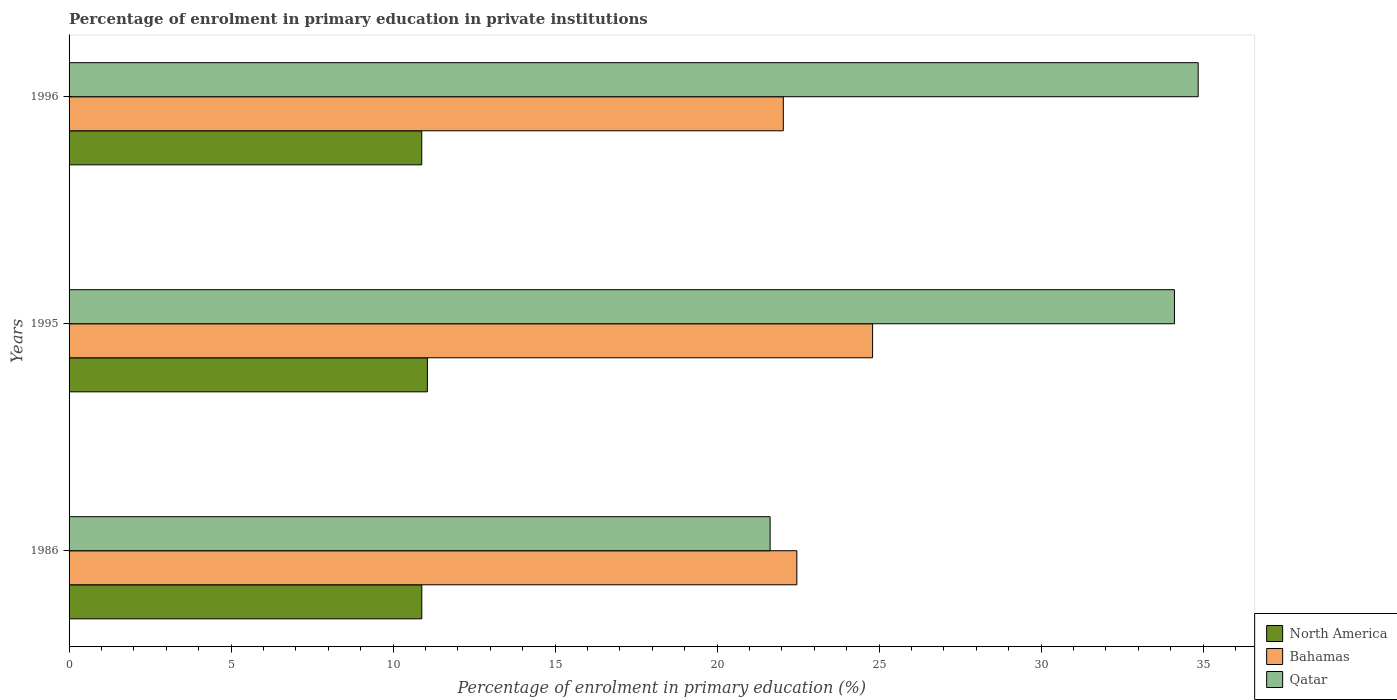How many different coloured bars are there?
Offer a terse response. 3. Are the number of bars per tick equal to the number of legend labels?
Your answer should be compact. Yes. How many bars are there on the 2nd tick from the top?
Keep it short and to the point. 3. How many bars are there on the 1st tick from the bottom?
Provide a succinct answer. 3. In how many cases, is the number of bars for a given year not equal to the number of legend labels?
Provide a short and direct response. 0. What is the percentage of enrolment in primary education in Bahamas in 1995?
Your answer should be compact. 24.8. Across all years, what is the maximum percentage of enrolment in primary education in Qatar?
Your answer should be very brief. 34.85. Across all years, what is the minimum percentage of enrolment in primary education in Qatar?
Keep it short and to the point. 21.64. In which year was the percentage of enrolment in primary education in Bahamas minimum?
Your response must be concise. 1996. What is the total percentage of enrolment in primary education in Bahamas in the graph?
Offer a very short reply. 69.3. What is the difference between the percentage of enrolment in primary education in Qatar in 1986 and that in 1996?
Make the answer very short. -13.21. What is the difference between the percentage of enrolment in primary education in Bahamas in 1995 and the percentage of enrolment in primary education in Qatar in 1986?
Keep it short and to the point. 3.16. What is the average percentage of enrolment in primary education in North America per year?
Provide a succinct answer. 10.94. In the year 1996, what is the difference between the percentage of enrolment in primary education in Qatar and percentage of enrolment in primary education in Bahamas?
Provide a succinct answer. 12.8. What is the ratio of the percentage of enrolment in primary education in North America in 1986 to that in 1996?
Your response must be concise. 1. Is the difference between the percentage of enrolment in primary education in Qatar in 1986 and 1996 greater than the difference between the percentage of enrolment in primary education in Bahamas in 1986 and 1996?
Give a very brief answer. No. What is the difference between the highest and the second highest percentage of enrolment in primary education in North America?
Ensure brevity in your answer.  0.17. What is the difference between the highest and the lowest percentage of enrolment in primary education in Bahamas?
Your response must be concise. 2.76. In how many years, is the percentage of enrolment in primary education in North America greater than the average percentage of enrolment in primary education in North America taken over all years?
Provide a succinct answer. 1. Is the sum of the percentage of enrolment in primary education in Qatar in 1995 and 1996 greater than the maximum percentage of enrolment in primary education in North America across all years?
Keep it short and to the point. Yes. What does the 1st bar from the top in 1995 represents?
Your response must be concise. Qatar. What does the 2nd bar from the bottom in 1986 represents?
Provide a short and direct response. Bahamas. How many bars are there?
Make the answer very short. 9. Are all the bars in the graph horizontal?
Make the answer very short. Yes. Does the graph contain any zero values?
Offer a terse response. No. Does the graph contain grids?
Keep it short and to the point. No. Where does the legend appear in the graph?
Ensure brevity in your answer.  Bottom right. How many legend labels are there?
Give a very brief answer. 3. What is the title of the graph?
Your answer should be compact. Percentage of enrolment in primary education in private institutions. Does "Malaysia" appear as one of the legend labels in the graph?
Make the answer very short. No. What is the label or title of the X-axis?
Your answer should be compact. Percentage of enrolment in primary education (%). What is the Percentage of enrolment in primary education (%) in North America in 1986?
Offer a terse response. 10.89. What is the Percentage of enrolment in primary education (%) in Bahamas in 1986?
Offer a terse response. 22.46. What is the Percentage of enrolment in primary education (%) of Qatar in 1986?
Offer a terse response. 21.64. What is the Percentage of enrolment in primary education (%) in North America in 1995?
Offer a terse response. 11.06. What is the Percentage of enrolment in primary education (%) in Bahamas in 1995?
Your answer should be compact. 24.8. What is the Percentage of enrolment in primary education (%) in Qatar in 1995?
Offer a very short reply. 34.11. What is the Percentage of enrolment in primary education (%) in North America in 1996?
Offer a terse response. 10.88. What is the Percentage of enrolment in primary education (%) of Bahamas in 1996?
Your answer should be very brief. 22.04. What is the Percentage of enrolment in primary education (%) of Qatar in 1996?
Keep it short and to the point. 34.85. Across all years, what is the maximum Percentage of enrolment in primary education (%) in North America?
Provide a short and direct response. 11.06. Across all years, what is the maximum Percentage of enrolment in primary education (%) in Bahamas?
Your response must be concise. 24.8. Across all years, what is the maximum Percentage of enrolment in primary education (%) of Qatar?
Ensure brevity in your answer.  34.85. Across all years, what is the minimum Percentage of enrolment in primary education (%) of North America?
Your response must be concise. 10.88. Across all years, what is the minimum Percentage of enrolment in primary education (%) of Bahamas?
Your answer should be very brief. 22.04. Across all years, what is the minimum Percentage of enrolment in primary education (%) of Qatar?
Your answer should be compact. 21.64. What is the total Percentage of enrolment in primary education (%) of North America in the graph?
Provide a short and direct response. 32.83. What is the total Percentage of enrolment in primary education (%) in Bahamas in the graph?
Give a very brief answer. 69.3. What is the total Percentage of enrolment in primary education (%) in Qatar in the graph?
Your response must be concise. 90.6. What is the difference between the Percentage of enrolment in primary education (%) of North America in 1986 and that in 1995?
Make the answer very short. -0.17. What is the difference between the Percentage of enrolment in primary education (%) of Bahamas in 1986 and that in 1995?
Provide a succinct answer. -2.34. What is the difference between the Percentage of enrolment in primary education (%) of Qatar in 1986 and that in 1995?
Make the answer very short. -12.48. What is the difference between the Percentage of enrolment in primary education (%) of North America in 1986 and that in 1996?
Your response must be concise. 0. What is the difference between the Percentage of enrolment in primary education (%) of Bahamas in 1986 and that in 1996?
Keep it short and to the point. 0.42. What is the difference between the Percentage of enrolment in primary education (%) of Qatar in 1986 and that in 1996?
Offer a very short reply. -13.21. What is the difference between the Percentage of enrolment in primary education (%) in North America in 1995 and that in 1996?
Provide a short and direct response. 0.17. What is the difference between the Percentage of enrolment in primary education (%) of Bahamas in 1995 and that in 1996?
Offer a terse response. 2.76. What is the difference between the Percentage of enrolment in primary education (%) in Qatar in 1995 and that in 1996?
Ensure brevity in your answer.  -0.73. What is the difference between the Percentage of enrolment in primary education (%) of North America in 1986 and the Percentage of enrolment in primary education (%) of Bahamas in 1995?
Make the answer very short. -13.91. What is the difference between the Percentage of enrolment in primary education (%) in North America in 1986 and the Percentage of enrolment in primary education (%) in Qatar in 1995?
Offer a very short reply. -23.23. What is the difference between the Percentage of enrolment in primary education (%) of Bahamas in 1986 and the Percentage of enrolment in primary education (%) of Qatar in 1995?
Offer a terse response. -11.65. What is the difference between the Percentage of enrolment in primary education (%) in North America in 1986 and the Percentage of enrolment in primary education (%) in Bahamas in 1996?
Provide a succinct answer. -11.16. What is the difference between the Percentage of enrolment in primary education (%) in North America in 1986 and the Percentage of enrolment in primary education (%) in Qatar in 1996?
Your answer should be very brief. -23.96. What is the difference between the Percentage of enrolment in primary education (%) in Bahamas in 1986 and the Percentage of enrolment in primary education (%) in Qatar in 1996?
Make the answer very short. -12.39. What is the difference between the Percentage of enrolment in primary education (%) of North America in 1995 and the Percentage of enrolment in primary education (%) of Bahamas in 1996?
Your answer should be compact. -10.99. What is the difference between the Percentage of enrolment in primary education (%) of North America in 1995 and the Percentage of enrolment in primary education (%) of Qatar in 1996?
Ensure brevity in your answer.  -23.79. What is the difference between the Percentage of enrolment in primary education (%) in Bahamas in 1995 and the Percentage of enrolment in primary education (%) in Qatar in 1996?
Make the answer very short. -10.05. What is the average Percentage of enrolment in primary education (%) of North America per year?
Provide a short and direct response. 10.94. What is the average Percentage of enrolment in primary education (%) in Bahamas per year?
Provide a succinct answer. 23.1. What is the average Percentage of enrolment in primary education (%) of Qatar per year?
Provide a short and direct response. 30.2. In the year 1986, what is the difference between the Percentage of enrolment in primary education (%) in North America and Percentage of enrolment in primary education (%) in Bahamas?
Offer a terse response. -11.57. In the year 1986, what is the difference between the Percentage of enrolment in primary education (%) in North America and Percentage of enrolment in primary education (%) in Qatar?
Provide a succinct answer. -10.75. In the year 1986, what is the difference between the Percentage of enrolment in primary education (%) in Bahamas and Percentage of enrolment in primary education (%) in Qatar?
Your answer should be compact. 0.82. In the year 1995, what is the difference between the Percentage of enrolment in primary education (%) of North America and Percentage of enrolment in primary education (%) of Bahamas?
Your response must be concise. -13.74. In the year 1995, what is the difference between the Percentage of enrolment in primary education (%) in North America and Percentage of enrolment in primary education (%) in Qatar?
Make the answer very short. -23.06. In the year 1995, what is the difference between the Percentage of enrolment in primary education (%) of Bahamas and Percentage of enrolment in primary education (%) of Qatar?
Provide a succinct answer. -9.32. In the year 1996, what is the difference between the Percentage of enrolment in primary education (%) in North America and Percentage of enrolment in primary education (%) in Bahamas?
Your response must be concise. -11.16. In the year 1996, what is the difference between the Percentage of enrolment in primary education (%) in North America and Percentage of enrolment in primary education (%) in Qatar?
Your answer should be very brief. -23.96. In the year 1996, what is the difference between the Percentage of enrolment in primary education (%) in Bahamas and Percentage of enrolment in primary education (%) in Qatar?
Provide a succinct answer. -12.8. What is the ratio of the Percentage of enrolment in primary education (%) in North America in 1986 to that in 1995?
Provide a succinct answer. 0.98. What is the ratio of the Percentage of enrolment in primary education (%) of Bahamas in 1986 to that in 1995?
Make the answer very short. 0.91. What is the ratio of the Percentage of enrolment in primary education (%) of Qatar in 1986 to that in 1995?
Give a very brief answer. 0.63. What is the ratio of the Percentage of enrolment in primary education (%) in Qatar in 1986 to that in 1996?
Provide a succinct answer. 0.62. What is the ratio of the Percentage of enrolment in primary education (%) of North America in 1995 to that in 1996?
Your answer should be compact. 1.02. What is the ratio of the Percentage of enrolment in primary education (%) in Bahamas in 1995 to that in 1996?
Provide a short and direct response. 1.12. What is the ratio of the Percentage of enrolment in primary education (%) of Qatar in 1995 to that in 1996?
Keep it short and to the point. 0.98. What is the difference between the highest and the second highest Percentage of enrolment in primary education (%) of North America?
Ensure brevity in your answer.  0.17. What is the difference between the highest and the second highest Percentage of enrolment in primary education (%) in Bahamas?
Make the answer very short. 2.34. What is the difference between the highest and the second highest Percentage of enrolment in primary education (%) of Qatar?
Provide a succinct answer. 0.73. What is the difference between the highest and the lowest Percentage of enrolment in primary education (%) in North America?
Ensure brevity in your answer.  0.17. What is the difference between the highest and the lowest Percentage of enrolment in primary education (%) in Bahamas?
Ensure brevity in your answer.  2.76. What is the difference between the highest and the lowest Percentage of enrolment in primary education (%) in Qatar?
Provide a short and direct response. 13.21. 